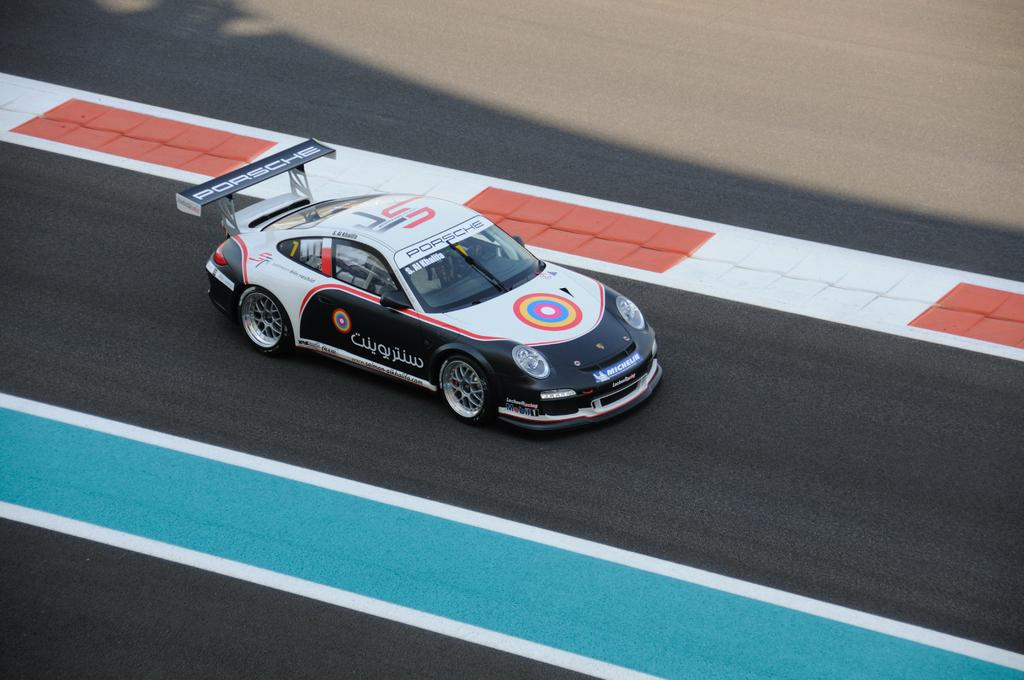What type of car is in the image? There is a black Porsche car in the image. What is the car doing in the image? The car is racing on a track. What grade does the car receive for its performance in the image? There is no grade given for the car's performance in the image. How many girls are present in the image? There are no girls present in the image; it features a black Porsche car racing on a track. 